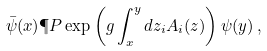Convert formula to latex. <formula><loc_0><loc_0><loc_500><loc_500>\bar { \psi } ( x ) \P P \exp \left ( g \int ^ { y } _ { x } d z _ { i } A _ { i } ( z ) \right ) \psi ( y ) \, ,</formula> 